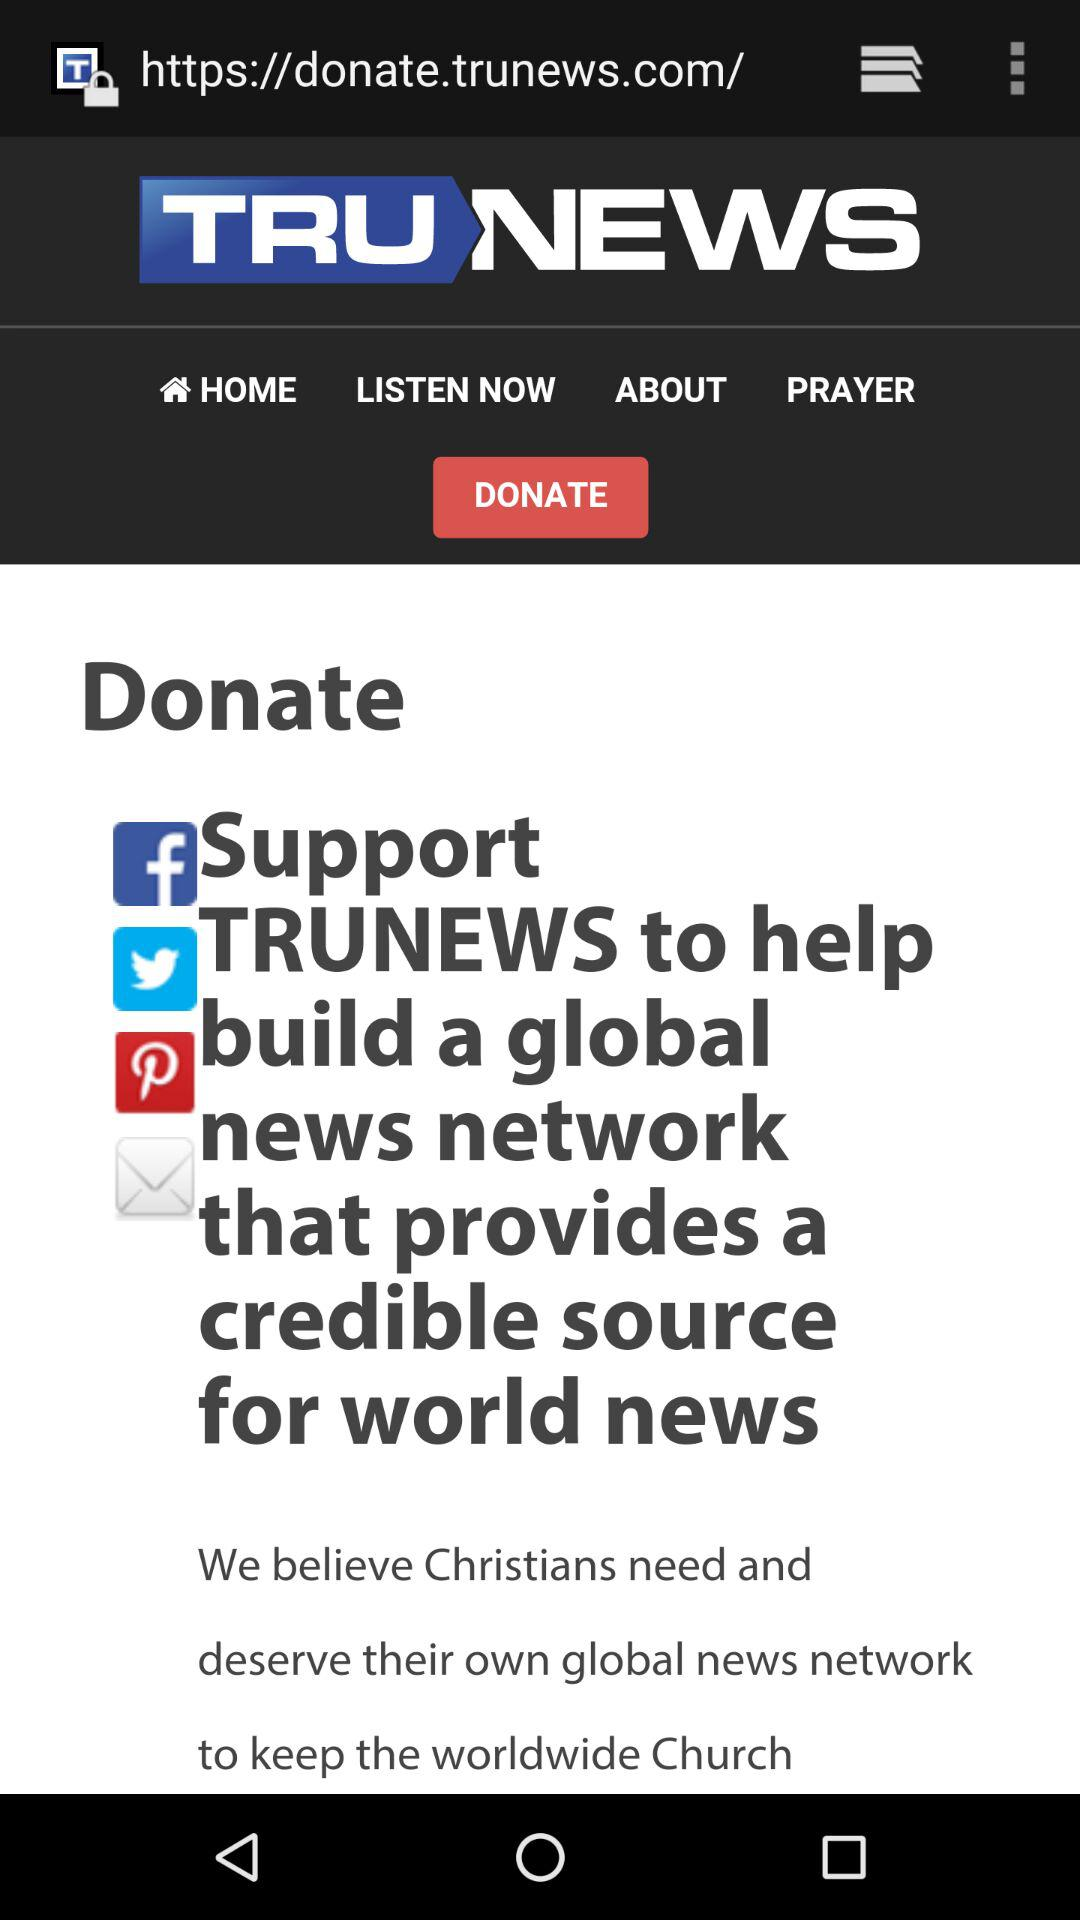What is the name of the news channel? The name of the news channel is "TRUNEWS". 